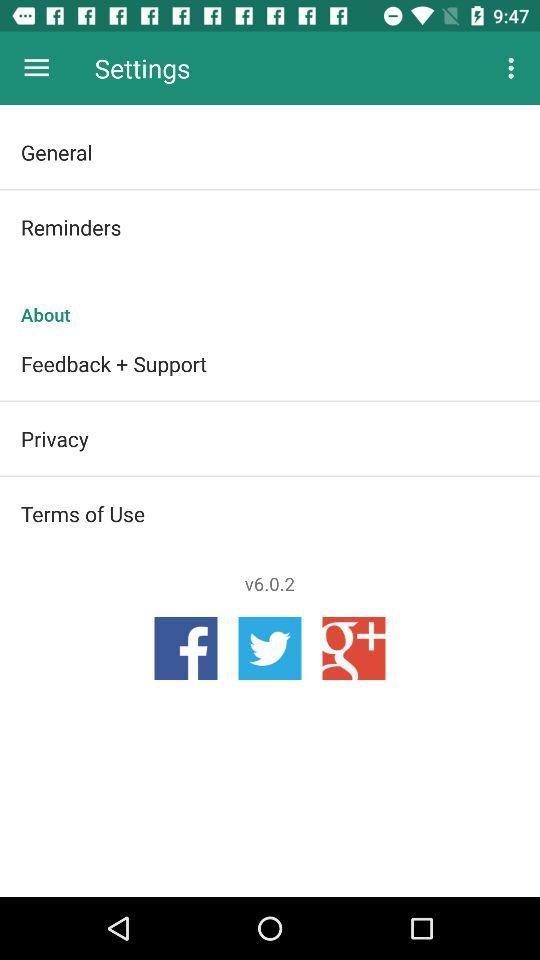Through which application can be share?
When the provided information is insufficient, respond with <no answer>. <no answer> 